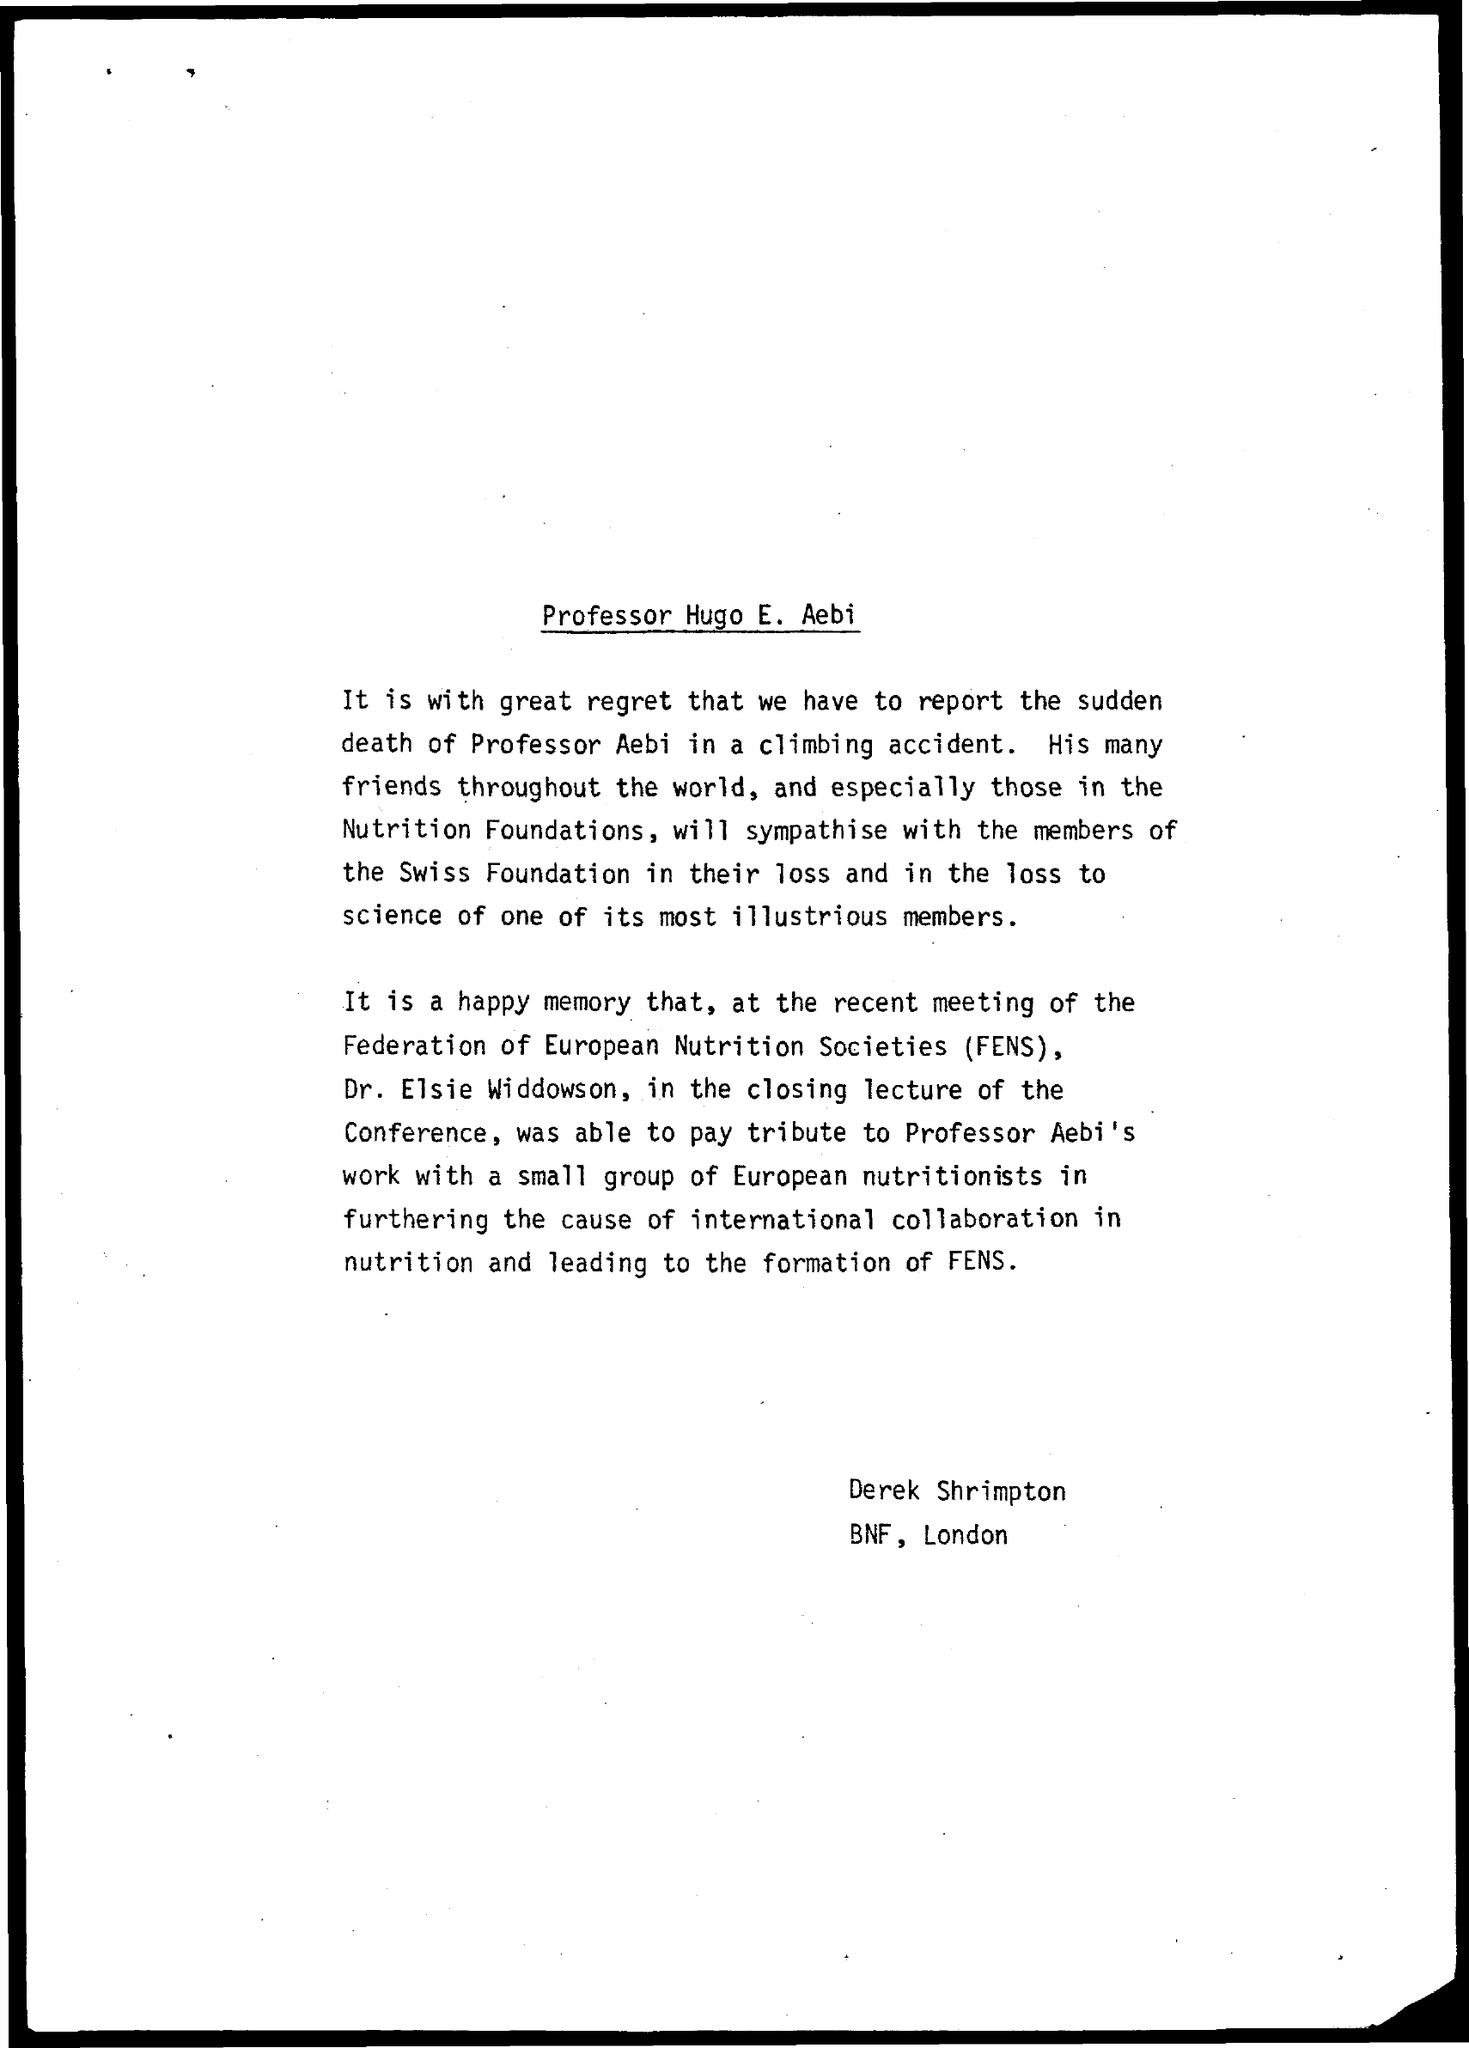Who is the Professor?
Give a very brief answer. Professor Aebi. 